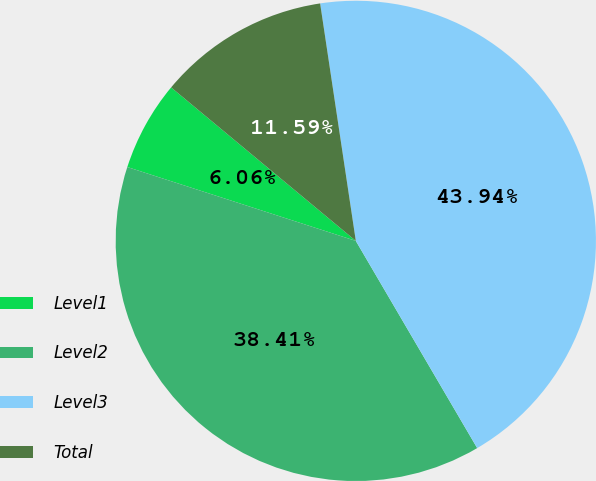<chart> <loc_0><loc_0><loc_500><loc_500><pie_chart><fcel>Level1<fcel>Level2<fcel>Level3<fcel>Total<nl><fcel>6.06%<fcel>38.41%<fcel>43.94%<fcel>11.59%<nl></chart> 